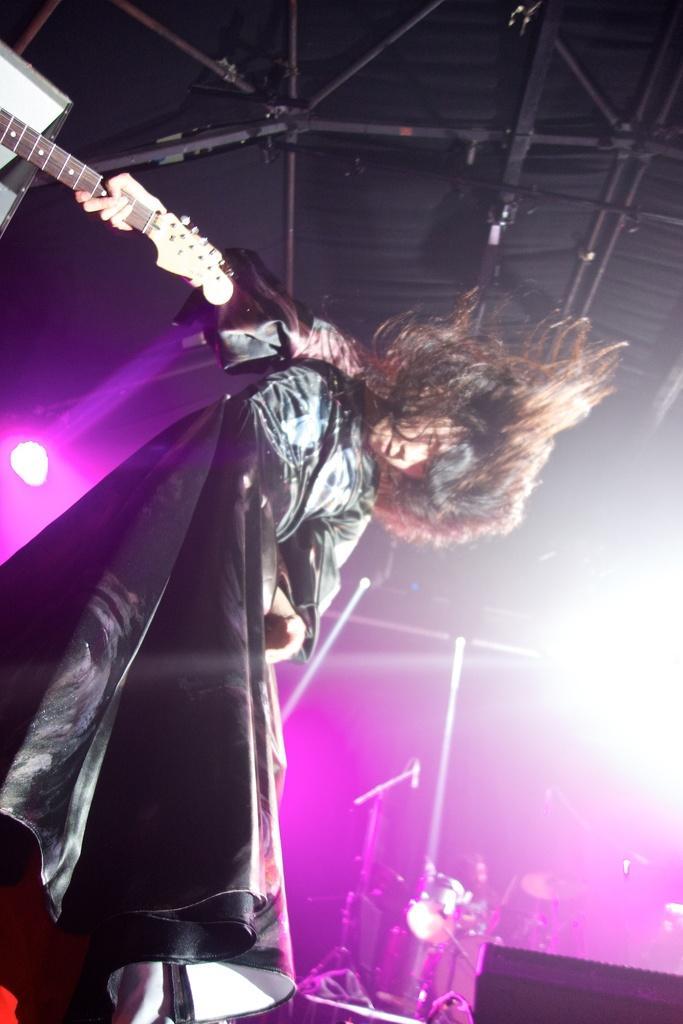Can you describe this image briefly? In this image a person is holding a guitar in his hand. Beside there is a person playing musical instrument. Few lights are attached to the rods. There are few mike stands on the stage. 